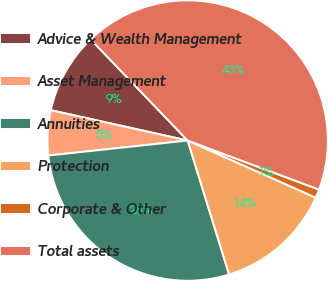Convert chart to OTSL. <chart><loc_0><loc_0><loc_500><loc_500><pie_chart><fcel>Advice & Wealth Management<fcel>Asset Management<fcel>Annuities<fcel>Protection<fcel>Corporate & Other<fcel>Total assets<nl><fcel>9.36%<fcel>5.18%<fcel>28.07%<fcel>13.55%<fcel>0.99%<fcel>42.85%<nl></chart> 